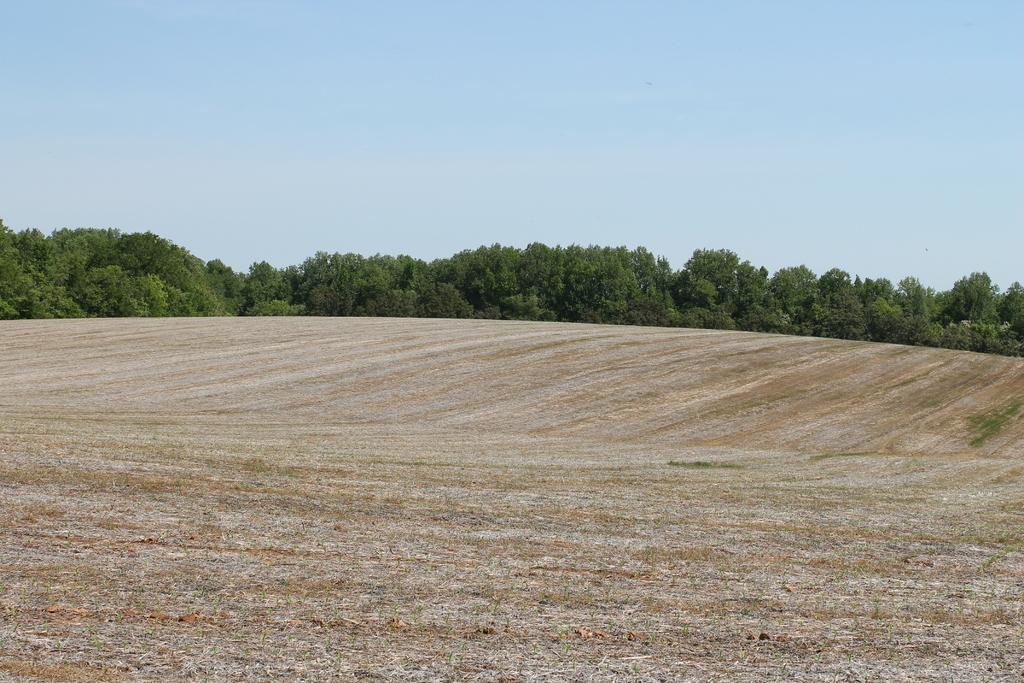What is the main feature in the foreground of the picture? There is barren land in the foreground of the picture. What can be seen in the middle of the picture? There are trees in the center of the picture. What is visible in the background of the picture? The background of the picture is the sky. How many babies are crawling on the barren land in the image? There are no babies present in the image; it features barren land and trees. Where is the library located in the image? There is no library present in the image; it features barren land, trees, and the sky. 